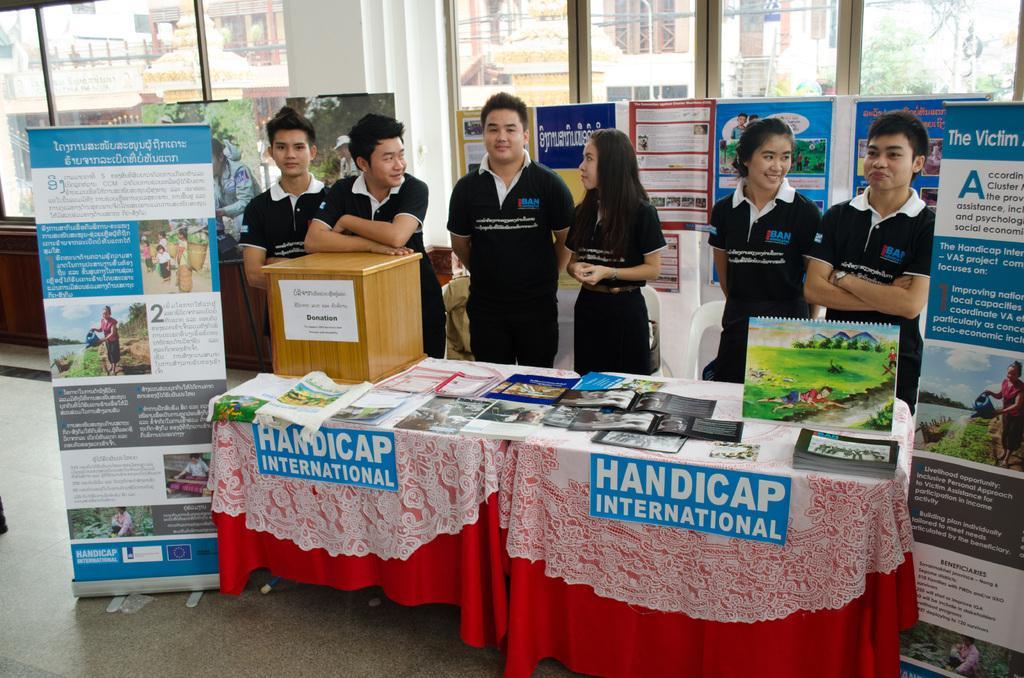In one or two sentences, can you explain what this image depicts? This is a picture taken in a room, there are a group of people standing in front of them there is a table. Table is covered with a cloth on the cloth there are some books on the cloth their mentioned a handicap international. On the table there is a wooden box. On the left side of this people there is a banner and the right side also having a banner. Background of this people is a window glass. 